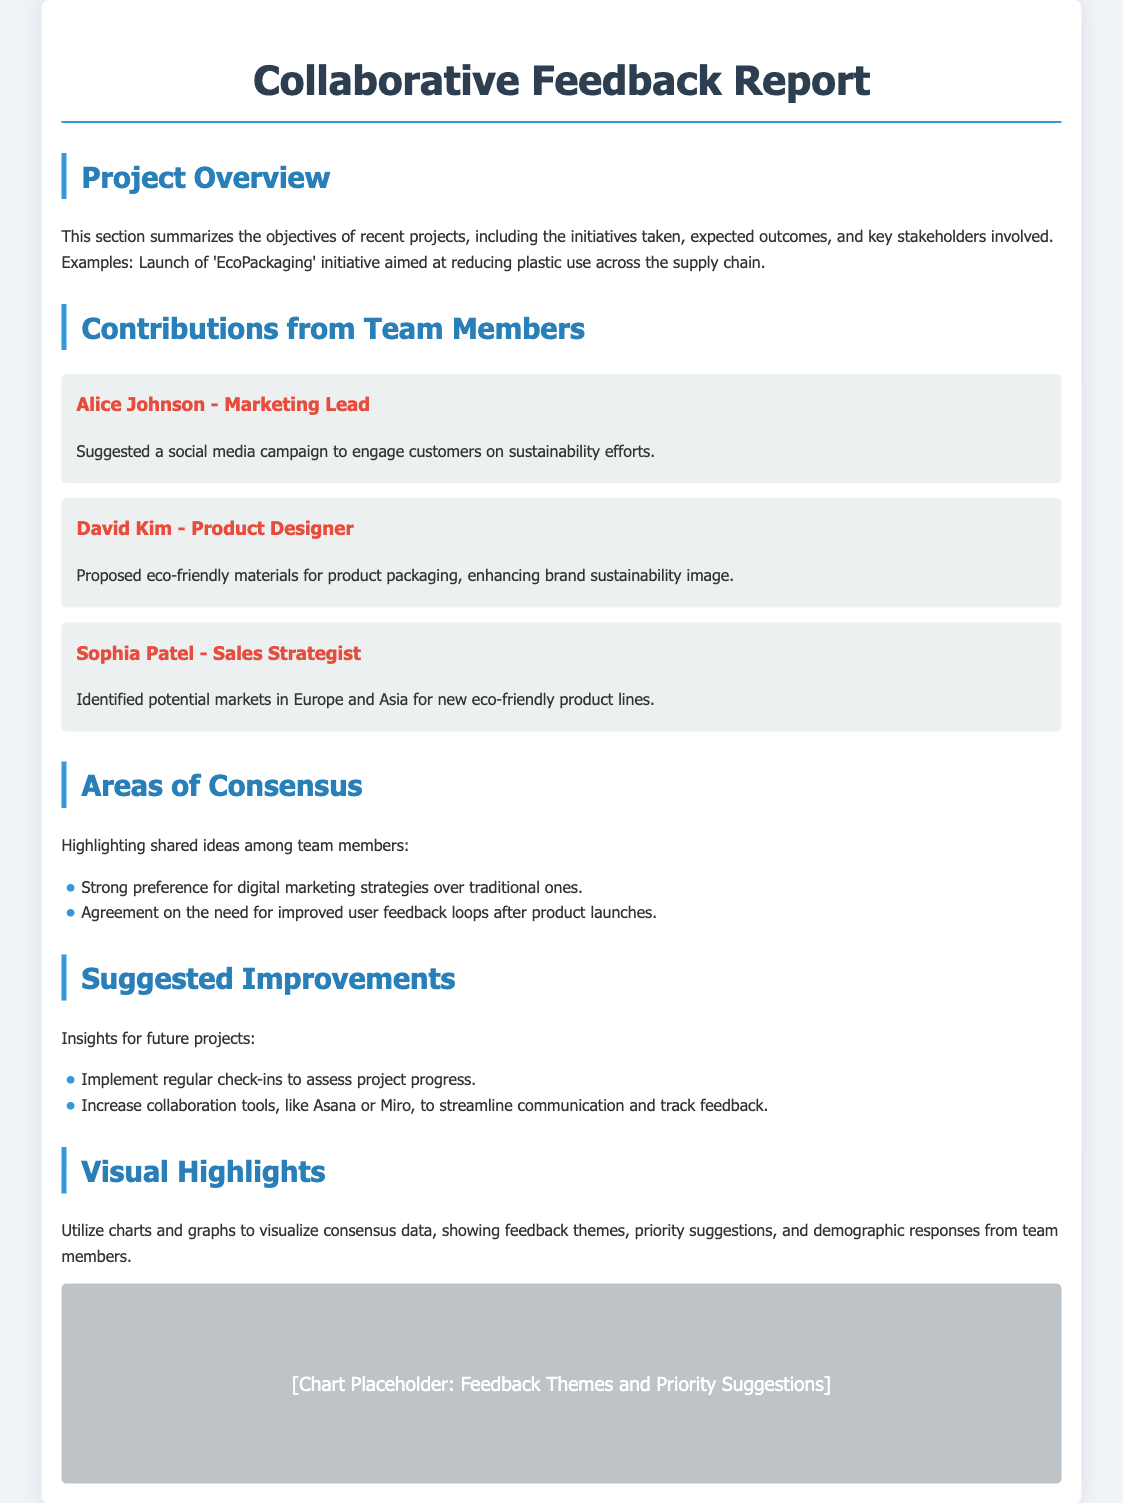what is the title of the report? The title is stated at the top of the document as “Collaborative Feedback Report.”
Answer: Collaborative Feedback Report who is the Marketing Lead? The document lists Alice Johnson as the Marketing Lead contributing to the project.
Answer: Alice Johnson what was a proposed initiative by David Kim? David Kim proposed using eco-friendly materials for product packaging, aiming to enhance the brand's sustainability image.
Answer: Eco-friendly materials which region did Sophia Patel identify for potential markets? Sophia Patel identified potential markets in Europe and Asia for eco-friendly product lines.
Answer: Europe and Asia what are the two areas of consensus mentioned? The document states a preference for digital marketing strategies and the need for improved user feedback loops.
Answer: Digital marketing strategies and improved user feedback loops how many suggestions for improvements are listed? The document lists two suggestions for improvements for future projects.
Answer: Two what type of visuals are suggested for feedback themes? The document suggests using charts and graphs to visualize feedback themes.
Answer: Charts and graphs which collaboration tools are mentioned for improving communication? The document mentions Asana and Miro as collaboration tools to streamline communication.
Answer: Asana and Miro who proposed a social media campaign? Alice Johnson suggested a social media campaign to engage customers on sustainability efforts.
Answer: Alice Johnson 